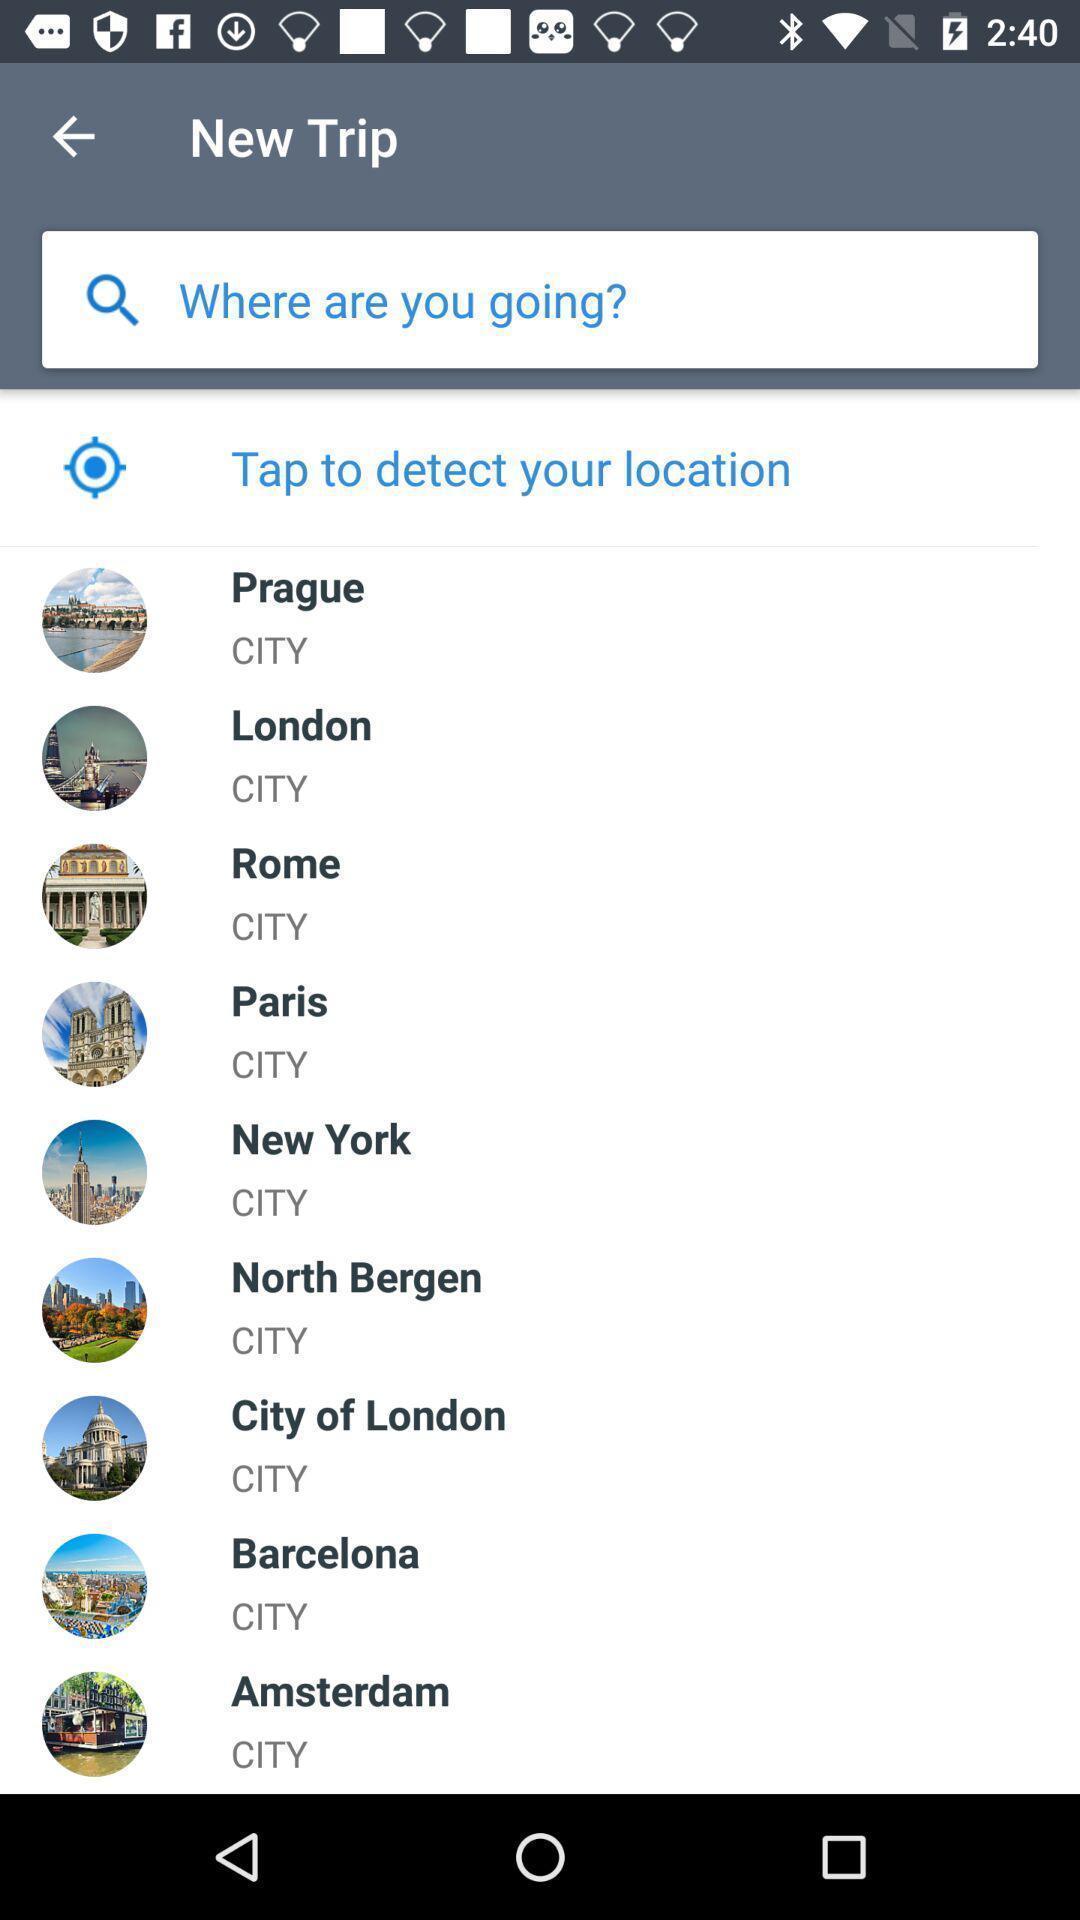Tell me about the visual elements in this screen capture. Page showing search bar with list of cities in application. 